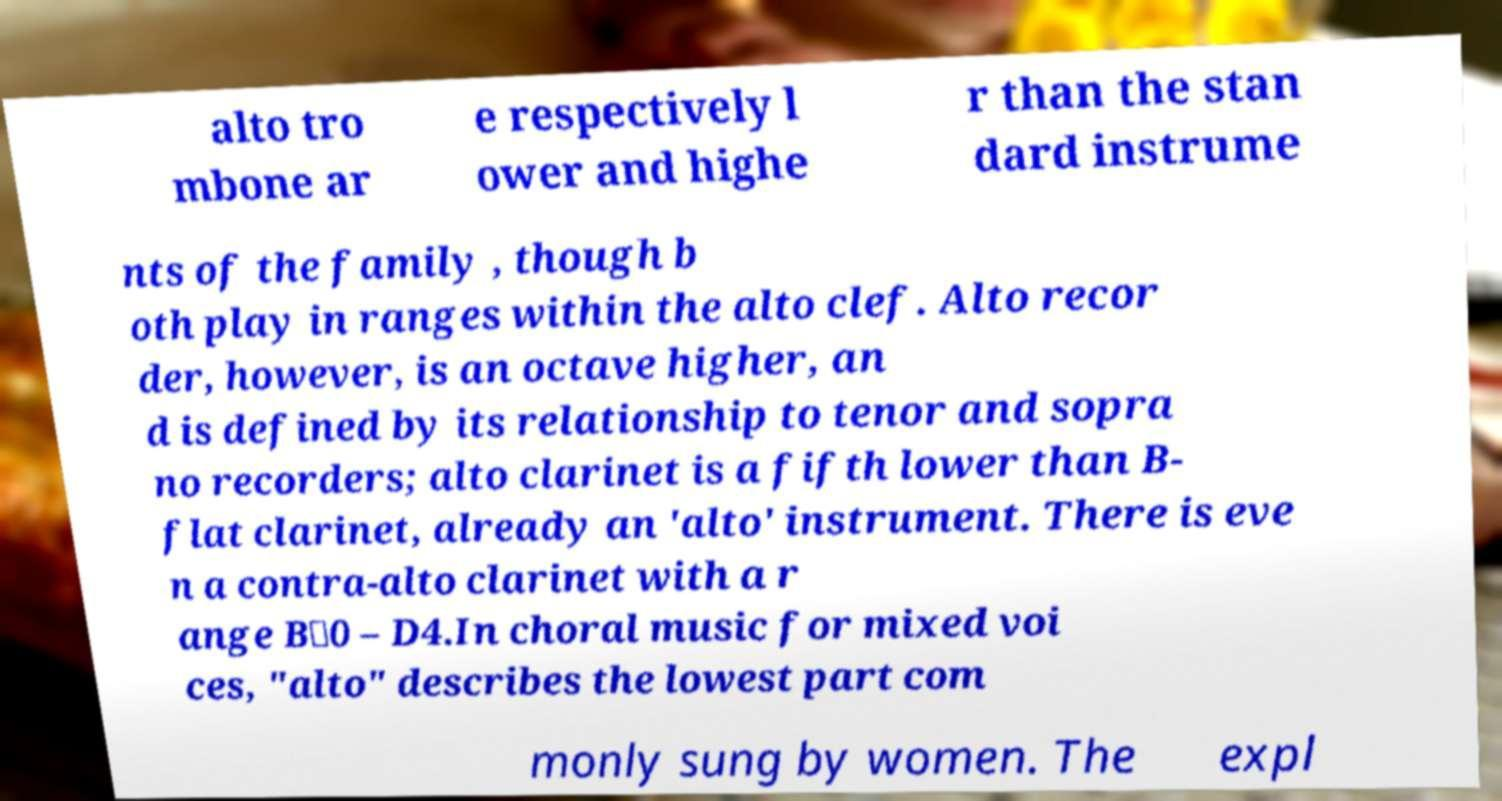There's text embedded in this image that I need extracted. Can you transcribe it verbatim? alto tro mbone ar e respectively l ower and highe r than the stan dard instrume nts of the family , though b oth play in ranges within the alto clef. Alto recor der, however, is an octave higher, an d is defined by its relationship to tenor and sopra no recorders; alto clarinet is a fifth lower than B- flat clarinet, already an 'alto' instrument. There is eve n a contra-alto clarinet with a r ange B♭0 – D4.In choral music for mixed voi ces, "alto" describes the lowest part com monly sung by women. The expl 